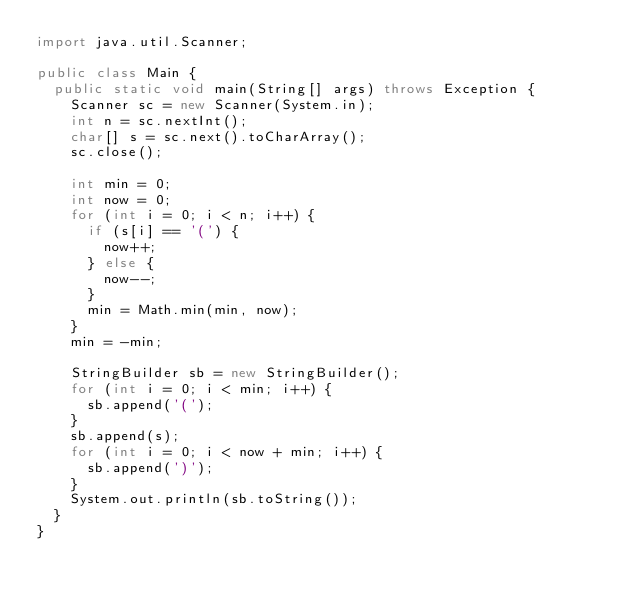<code> <loc_0><loc_0><loc_500><loc_500><_Java_>import java.util.Scanner;

public class Main {
	public static void main(String[] args) throws Exception {
		Scanner sc = new Scanner(System.in);
		int n = sc.nextInt();
		char[] s = sc.next().toCharArray();
		sc.close();

		int min = 0;
		int now = 0;
		for (int i = 0; i < n; i++) {
			if (s[i] == '(') {
				now++;
			} else {
				now--;
			}
			min = Math.min(min, now);
		}
		min = -min;

		StringBuilder sb = new StringBuilder();
		for (int i = 0; i < min; i++) {
			sb.append('(');
		}
		sb.append(s);
		for (int i = 0; i < now + min; i++) {
			sb.append(')');
		}
		System.out.println(sb.toString());
	}
}
</code> 